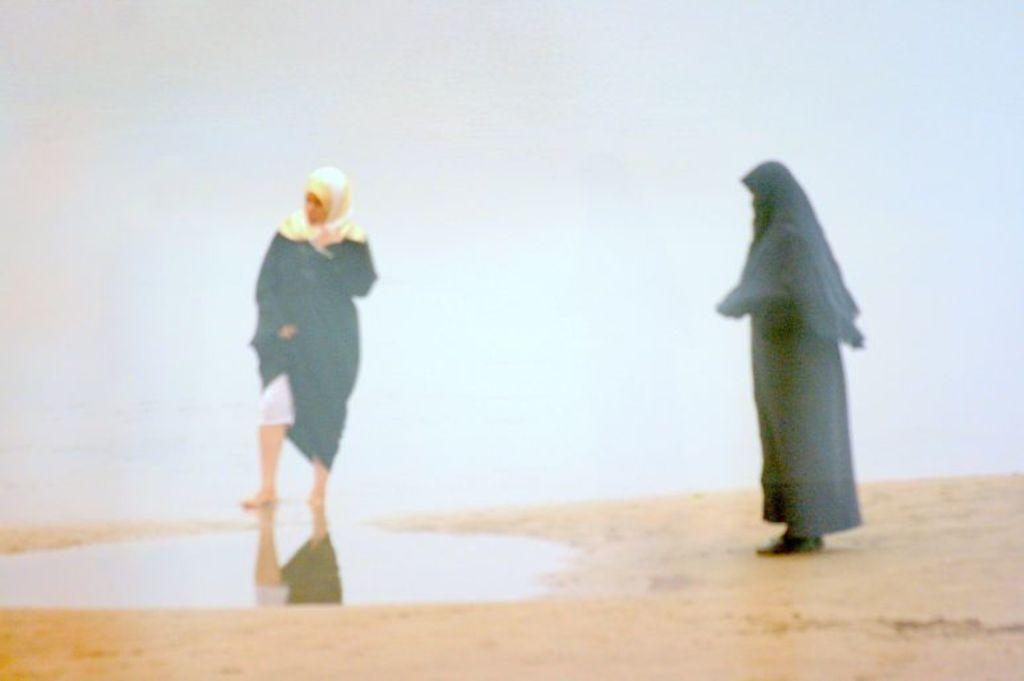How many people are in the image? There are two women in the image. What is the texture or material visible at the bottom of the image? There is sand towards the bottom of the image. What color is the background of the image? The background of the image is white in color. How many trees can be seen in the image? There are no trees visible in the image. Can you describe the kiss between the two women in the image? There is no kiss between the two women in the image. 